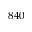<formula> <loc_0><loc_0><loc_500><loc_500>8 4 0</formula> 